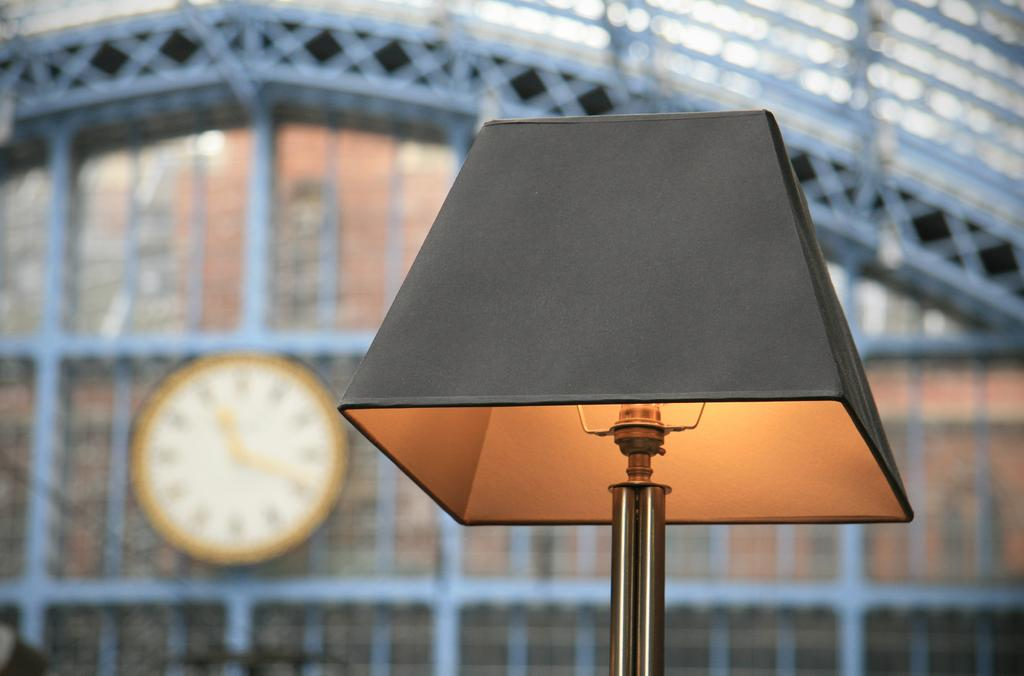What object is located on the right side of the image? There is a lamp on the right side of the image. What can be seen on the wall in the background of the image? There is a clock on the wall in the background of the image. What architectural feature is present at the top of the image? There is a railing at the top of the image. What type of loaf is being held by the person in the image? There is no person present in the image, and therefore no loaf can be observed. How many minutes are displayed on the clock in the image? The provided facts do not mention the time displayed on the clock, so it is impossible to determine the number of minutes. 